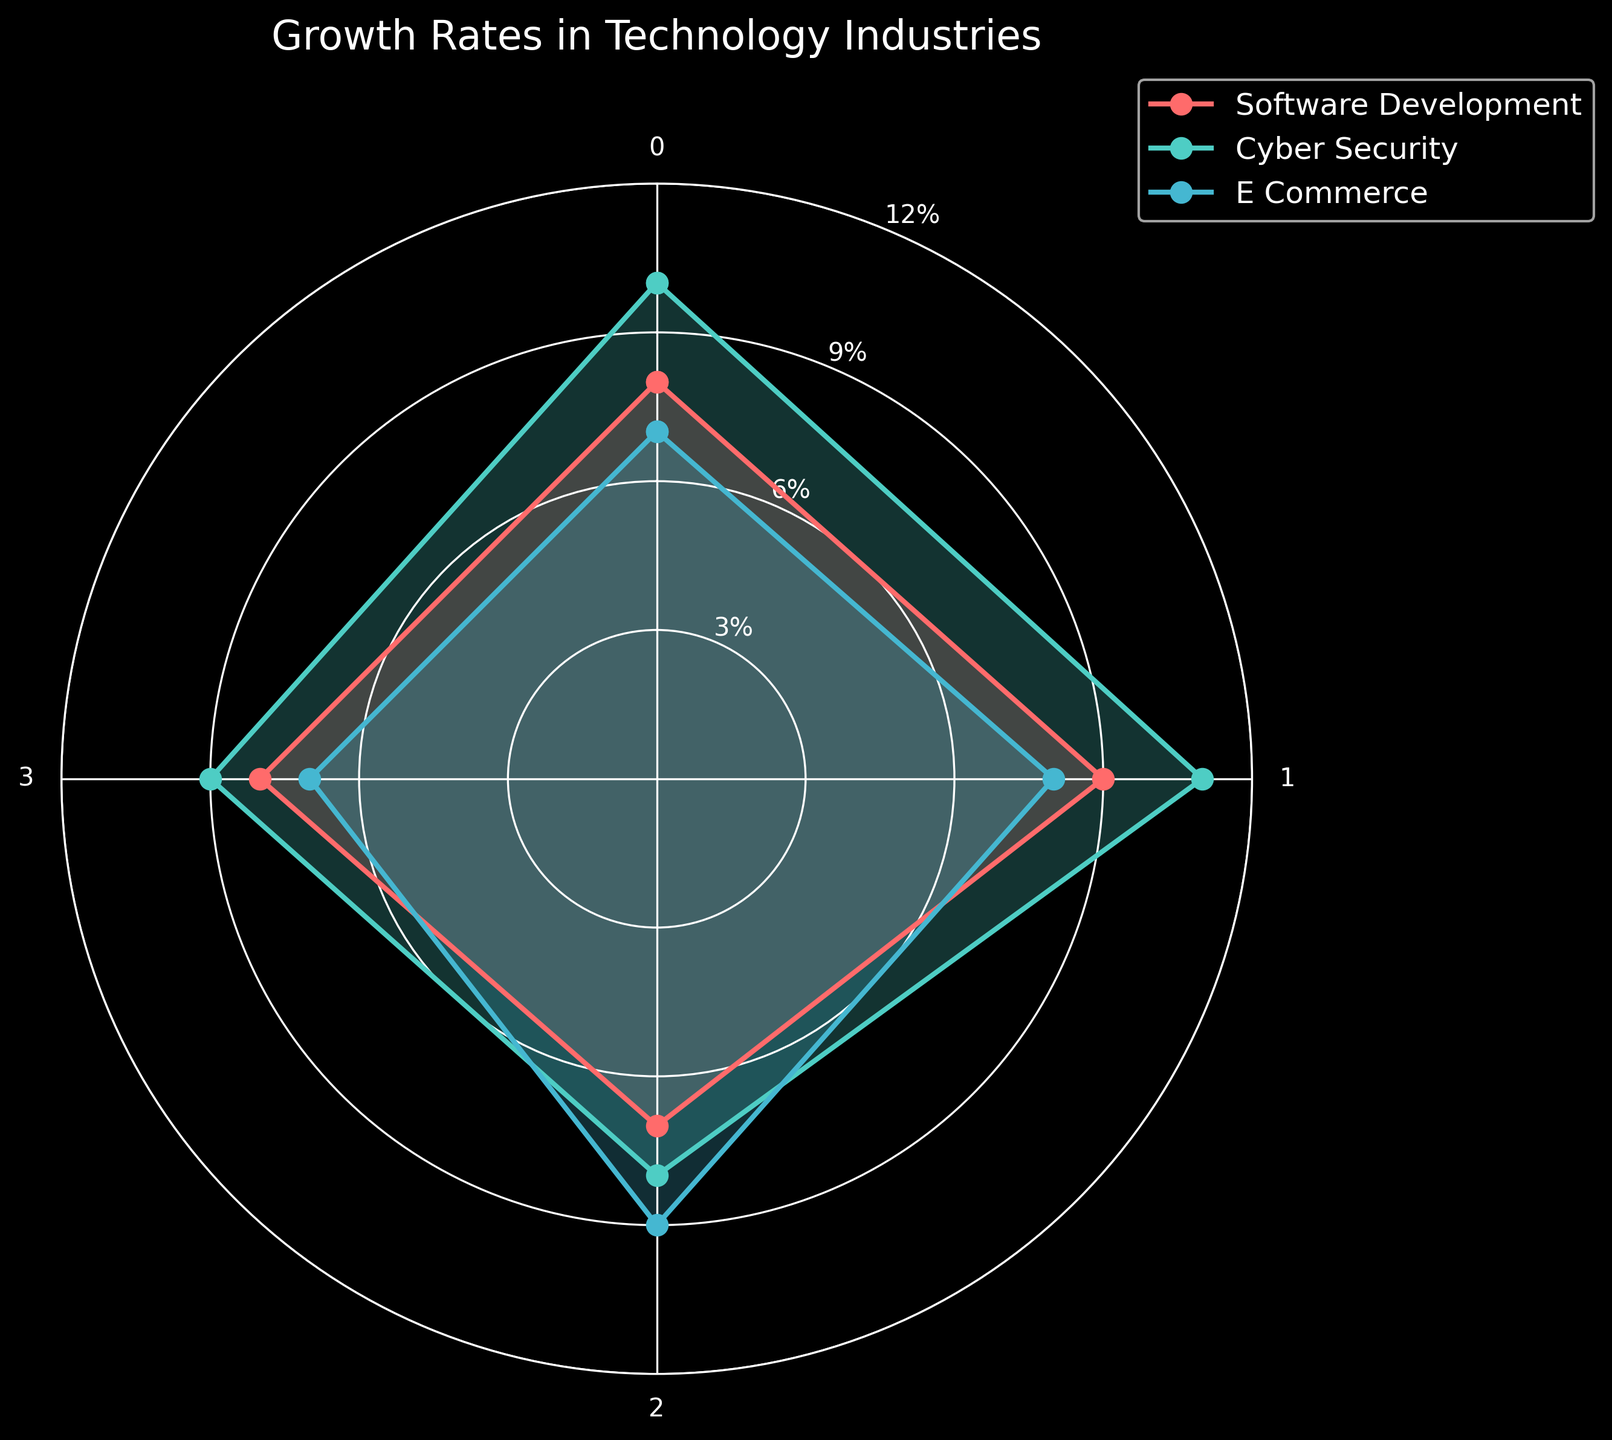How many industries are compared in the chart? The chart plots data for three industries, as indicated by the lines and labels: software development, cyber security, and e-commerce.
Answer: Three What is the highest average salary growth rate shown in the chart? By looking at the plot and identifying the peak points on the average salary growth rate axis, cyber security has the highest value at 10%.
Answer: 10% Which industry has the lowest average in teenager-friendly workshops and internship availability combined? Add the values for each industry in these two categories: software development (7+8=15), cyber security (8+9=17), e-commerce (9+7=16). The lowest is software development.
Answer: Software Development Between software development and retail, which one has a higher job openings growth rate? Compare the job openings growth rate points for software development (9%) and retail (3%).
Answer: Software Development Among the categories, which one shows the biggest difference in values between the highest and lowest industry? Calculate the difference for each category: average salary growth rate (10-2=8), job openings growth rate (11-3=8), teenager-friendly workshops (9-6=3), internship availability (9-4=5). The maximum difference is in average salary growth rate (8%) and job openings growth rate (8%).
Answer: Average Salary Growth Rate and Job Openings Growth Rate Which industry has the highest value for internship availability? Locate the highest point in the internship availability category. Cyber security has the highest value at 9%.
Answer: Cyber Security What is the overall trend in teenager-friendly workshops across industries? Identify the values for teenager-friendly workshops: software development (7), cyber security (8), e-commerce (9). The rates show a steady increase across these industries.
Answer: Increasing For the e-commerce industry, which category shows the smallest growth rate? Identify the smallest value for e-commerce across the categories. The smallest value is internship availability at 7.
Answer: Internship Availability Which two industries have the closest average salary growth rate? Compare the average salary growth rates: software development (8%), cyber security (10%), e-commerce (7%). Software development and e-commerce have the closest values, with only a 1% difference.
Answer: Software Development and E-commerce In the job openings growth rate category, how much higher is cyber security's value compared to e-commerce? Subtract the job openings growth rate of e-commerce (8%) from the job openings growth rate for cyber security (11%). The difference is 3%.
Answer: 3% 